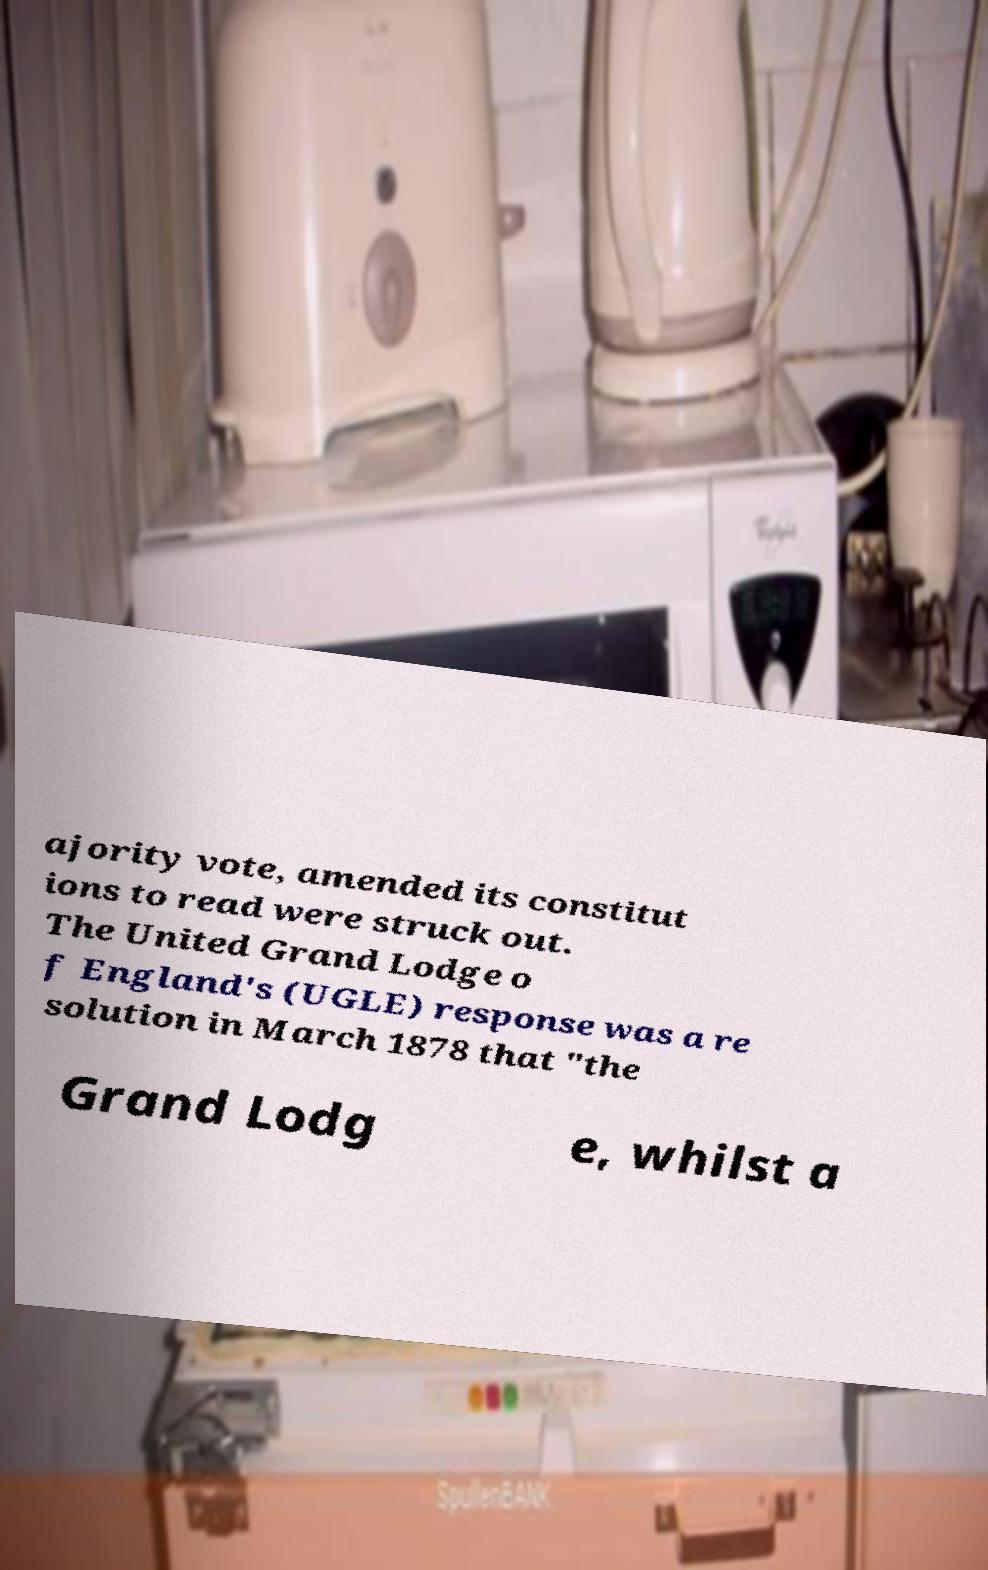Please read and relay the text visible in this image. What does it say? ajority vote, amended its constitut ions to read were struck out. The United Grand Lodge o f England's (UGLE) response was a re solution in March 1878 that "the Grand Lodg e, whilst a 